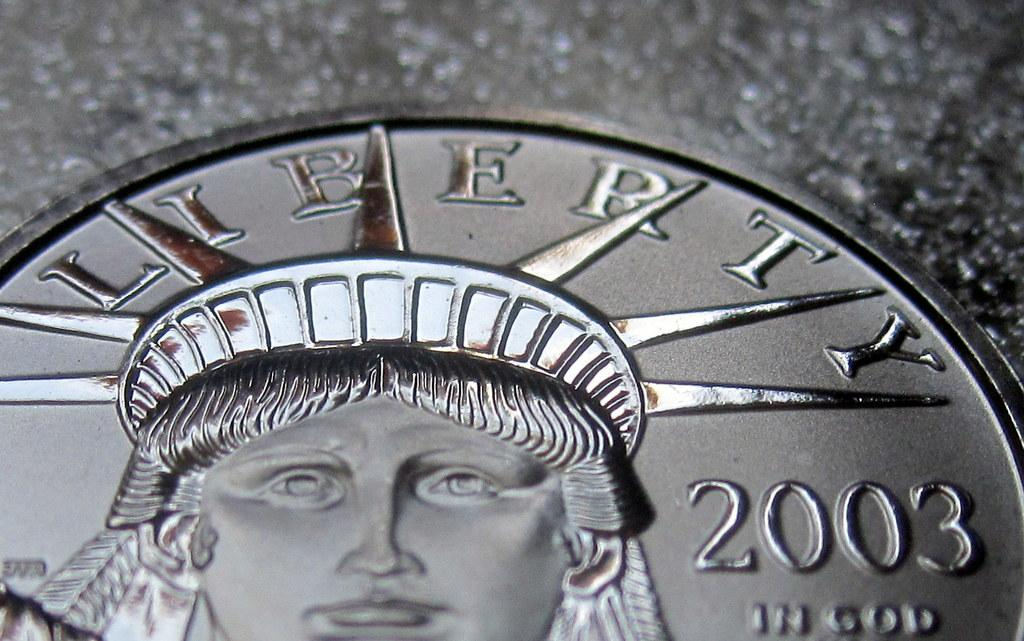<image>
Provide a brief description of the given image. A Liberty coin with the year 2003 on it. 